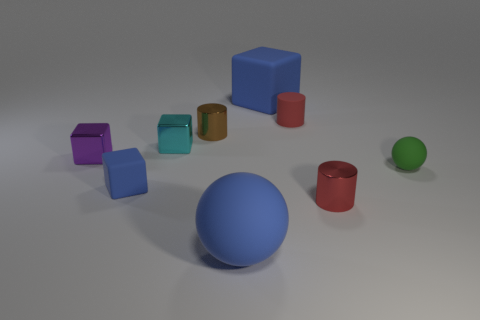Is there a cylinder behind the metal cylinder that is behind the tiny cylinder in front of the green rubber thing?
Give a very brief answer. Yes. How big is the brown metal object?
Provide a succinct answer. Small. There is a metallic cylinder in front of the green object; how big is it?
Your response must be concise. Small. There is a matte thing that is right of the rubber cylinder; is it the same size as the large sphere?
Your response must be concise. No. Are there any other things that are the same color as the large ball?
Your answer should be compact. Yes. The tiny red shiny thing is what shape?
Your response must be concise. Cylinder. What number of blue blocks are in front of the small brown metallic object and to the right of the brown metallic cylinder?
Your answer should be very brief. 0. Does the tiny rubber cube have the same color as the rubber cylinder?
Your answer should be very brief. No. There is a brown object that is the same shape as the small red metal thing; what is its material?
Make the answer very short. Metal. Are there the same number of cyan metallic blocks in front of the large rubber block and small balls that are behind the small blue matte thing?
Offer a very short reply. Yes. 